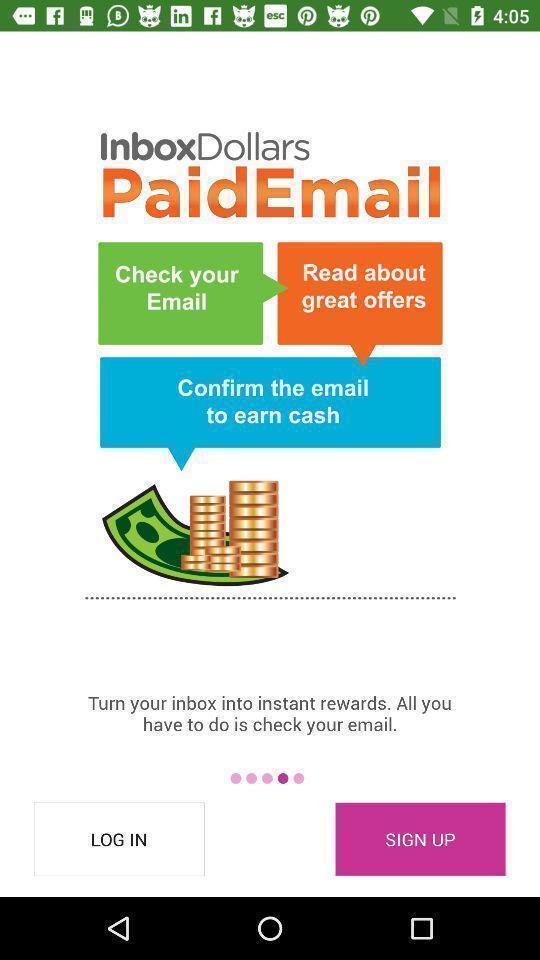Provide a detailed account of this screenshot. Welcome page. 